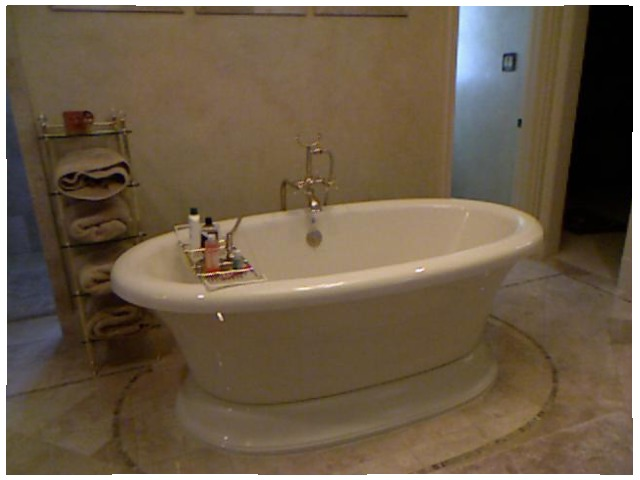<image>
Can you confirm if the towel is on the tub? No. The towel is not positioned on the tub. They may be near each other, but the towel is not supported by or resting on top of the tub. Is the towel on the bathtub? No. The towel is not positioned on the bathtub. They may be near each other, but the towel is not supported by or resting on top of the bathtub. Where is the shampoo in relation to the tub? Is it in the tub? Yes. The shampoo is contained within or inside the tub, showing a containment relationship. 